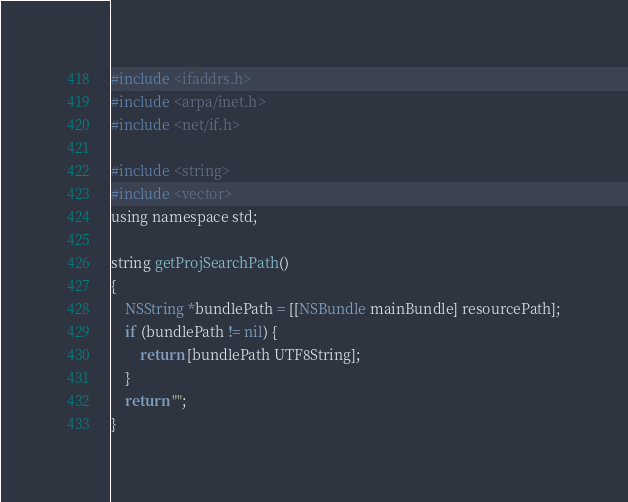Convert code to text. <code><loc_0><loc_0><loc_500><loc_500><_ObjectiveC_>
#include <ifaddrs.h>
#include <arpa/inet.h>
#include <net/if.h>

#include <string>
#include <vector>
using namespace std;

string getProjSearchPath()
{
    NSString *bundlePath = [[NSBundle mainBundle] resourcePath];
    if (bundlePath != nil) {
        return [bundlePath UTF8String];
    }
    return "";
}
</code> 